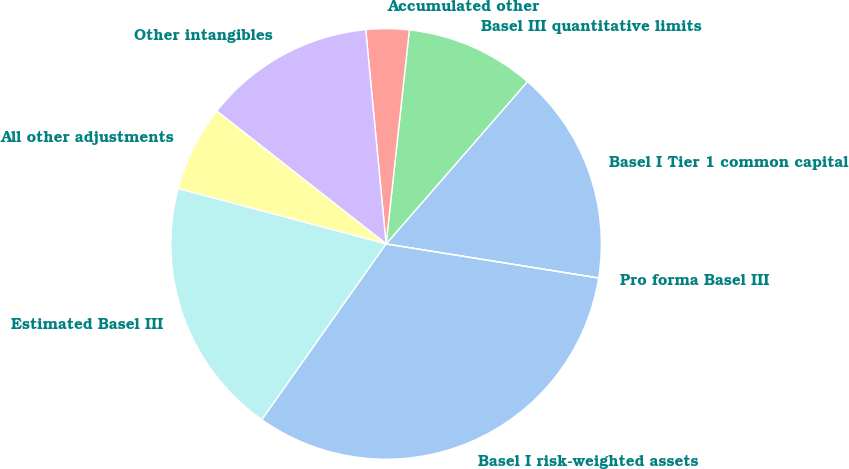Convert chart to OTSL. <chart><loc_0><loc_0><loc_500><loc_500><pie_chart><fcel>Basel I Tier 1 common capital<fcel>Basel III quantitative limits<fcel>Accumulated other<fcel>Other intangibles<fcel>All other adjustments<fcel>Estimated Basel III<fcel>Basel I risk-weighted assets<fcel>Pro forma Basel III<nl><fcel>16.13%<fcel>9.68%<fcel>3.23%<fcel>12.9%<fcel>6.45%<fcel>19.35%<fcel>32.26%<fcel>0.0%<nl></chart> 